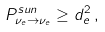<formula> <loc_0><loc_0><loc_500><loc_500>P ^ { s u n } _ { \nu _ { e } \to \nu _ { e } } \geq d _ { e } ^ { 2 } \, ,</formula> 